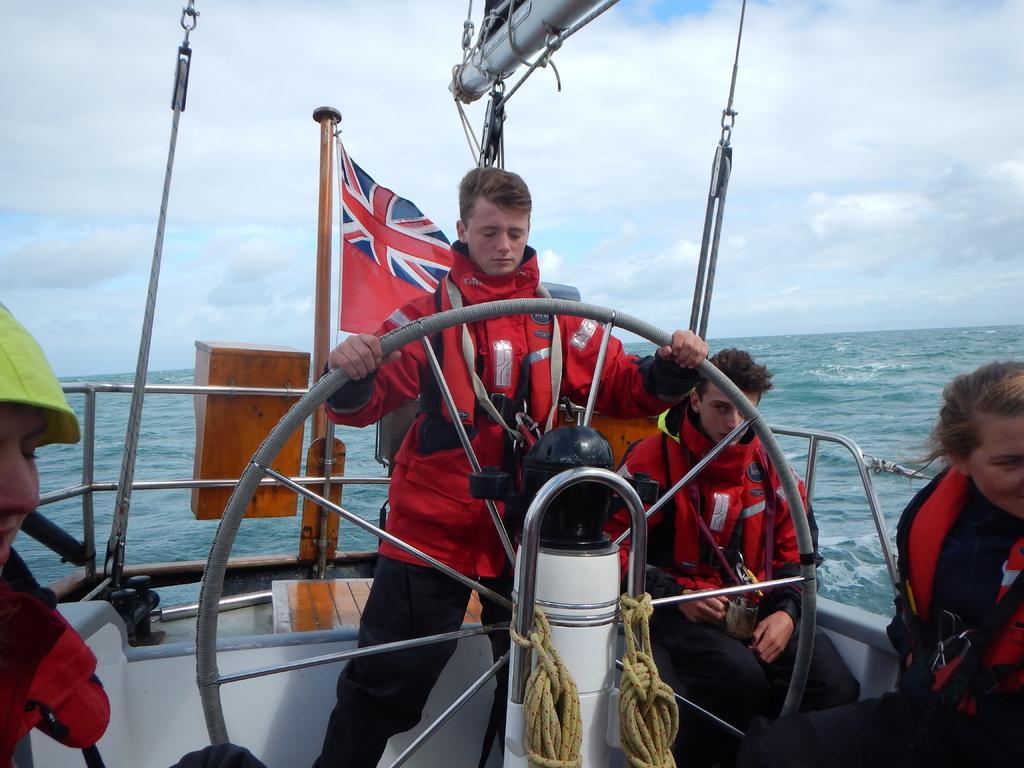Please provide a concise description of this image. In the picture I can see people on the boat among them the man who is standing is holding a wheel. I can also see a flag, poles, ropes and fence. I can also see the sky and the water. 